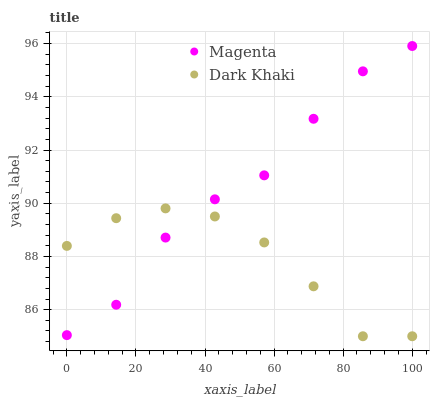Does Dark Khaki have the minimum area under the curve?
Answer yes or no. Yes. Does Magenta have the maximum area under the curve?
Answer yes or no. Yes. Does Magenta have the minimum area under the curve?
Answer yes or no. No. Is Dark Khaki the smoothest?
Answer yes or no. Yes. Is Magenta the roughest?
Answer yes or no. Yes. Is Magenta the smoothest?
Answer yes or no. No. Does Dark Khaki have the lowest value?
Answer yes or no. Yes. Does Magenta have the lowest value?
Answer yes or no. No. Does Magenta have the highest value?
Answer yes or no. Yes. Does Magenta intersect Dark Khaki?
Answer yes or no. Yes. Is Magenta less than Dark Khaki?
Answer yes or no. No. Is Magenta greater than Dark Khaki?
Answer yes or no. No. 